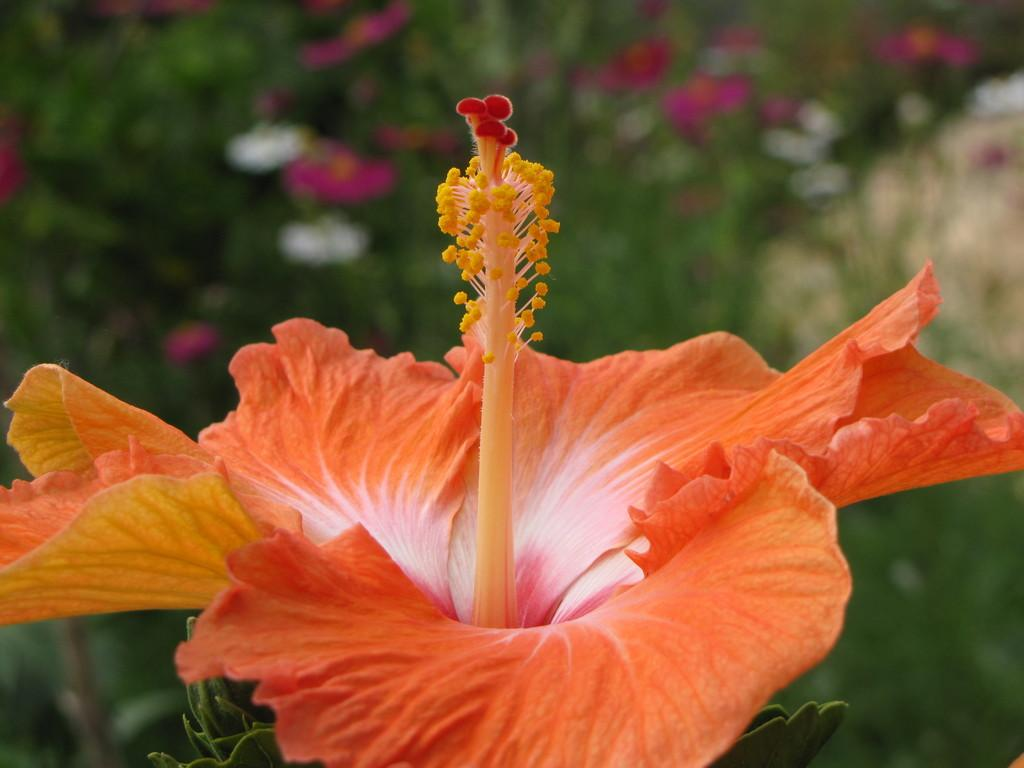What type of flower is in the picture? There is a hibiscus flower in the picture. Can you describe the background of the image? The background of the image is blurred. How many crows are sitting on the hibiscus flower in the image? There are no crows present in the image; it only features a hibiscus flower. What is the best way to reach the place where the hibiscus flower is located in the image? The image is a still photograph, so there is no way to reach the location of the hibiscus flower. 